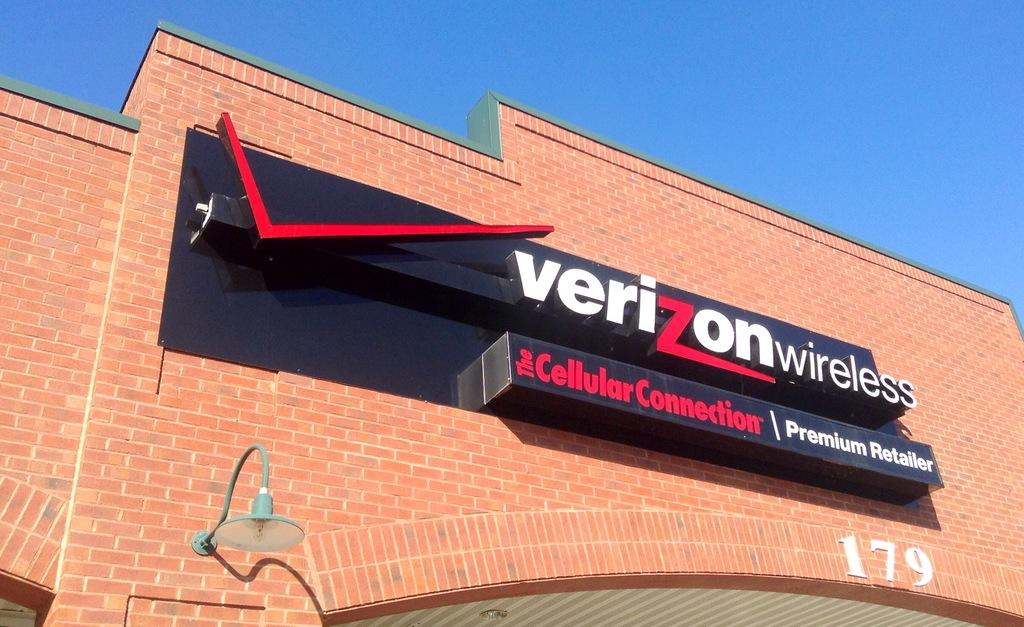<image>
Render a clear and concise summary of the photo. a storefront  with a sign on top for Verizon Wireles 